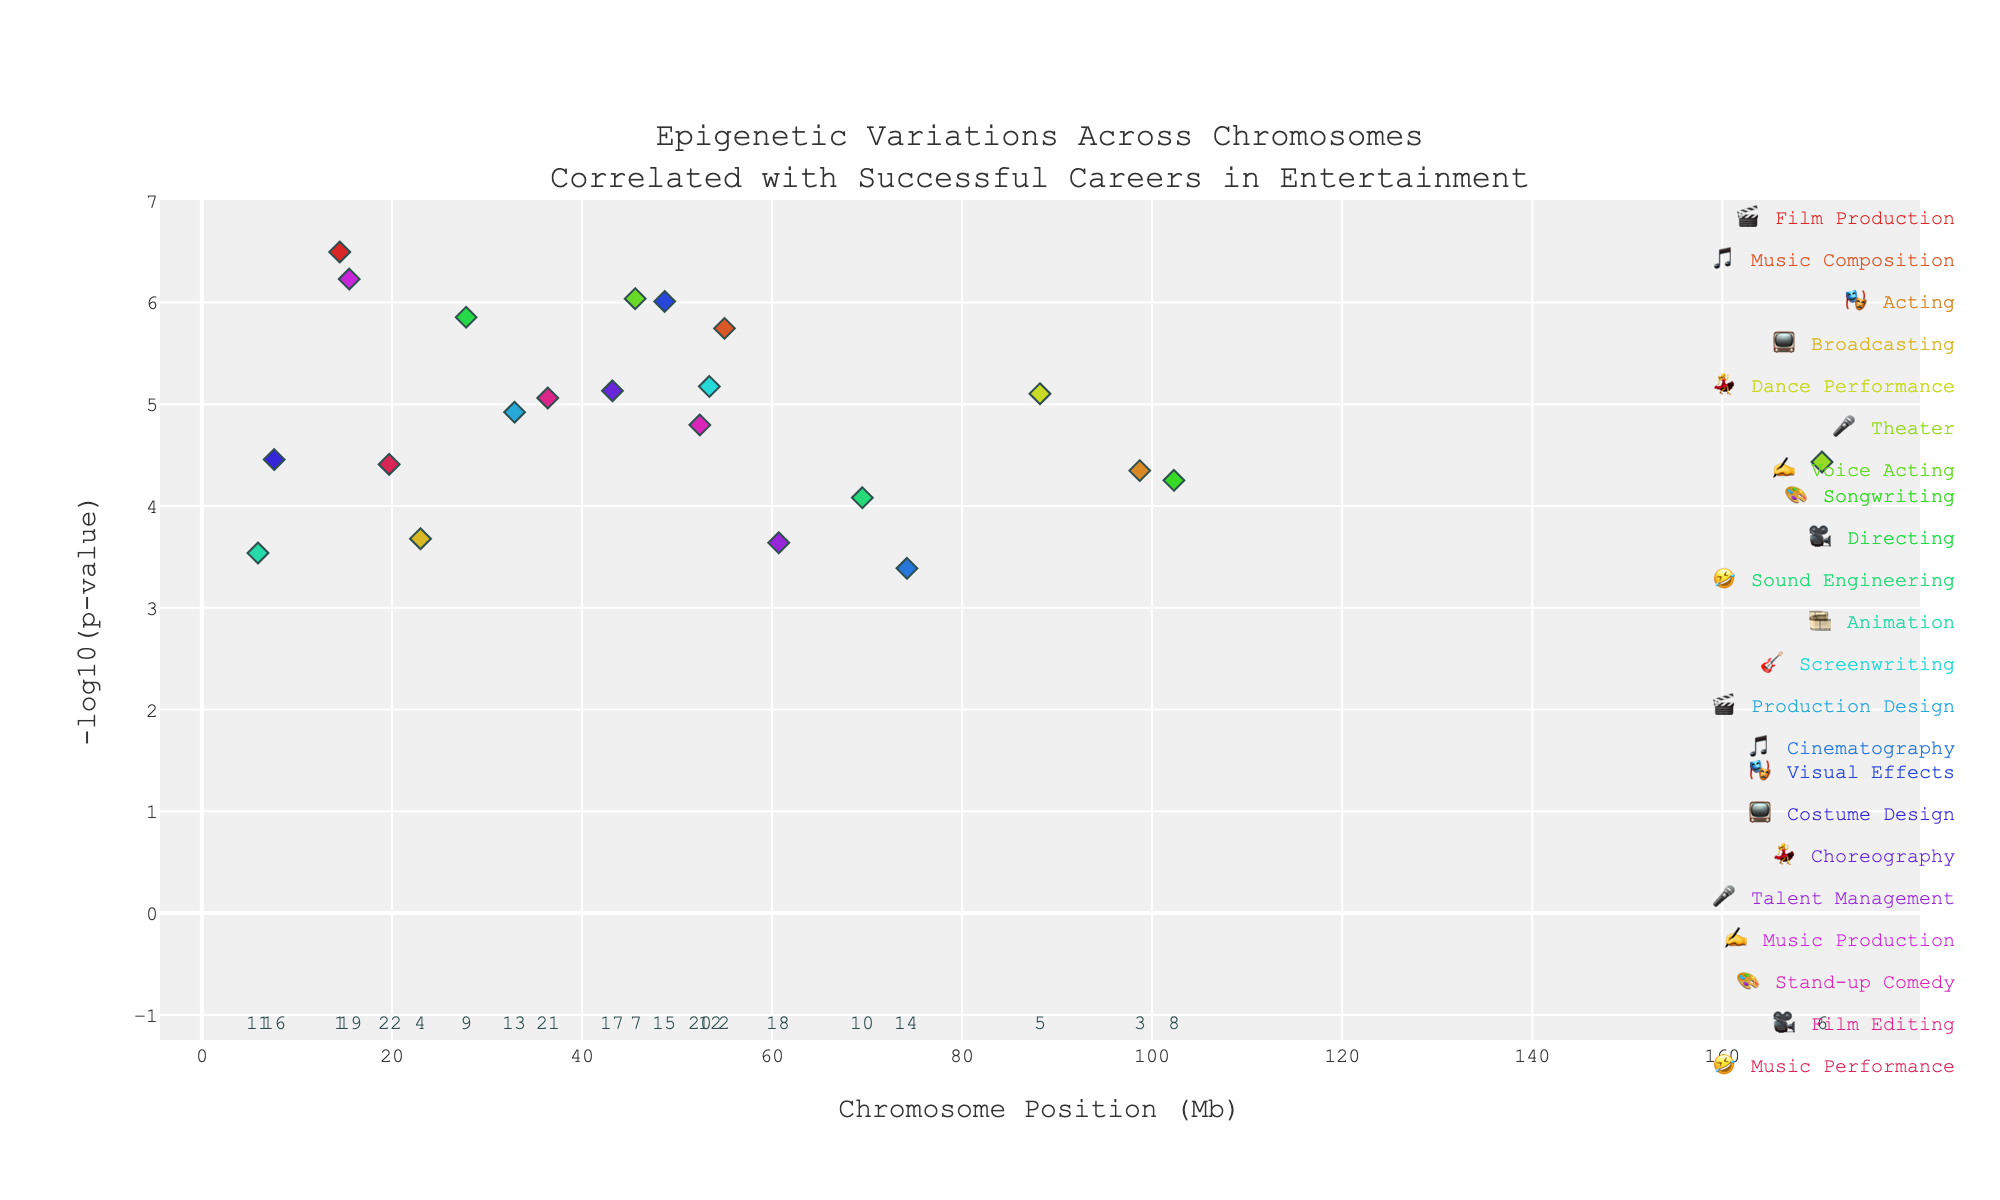What is the title of the plot? The title of the plot is usually located at the top center of the figure. It provides an overview of what the plot is about. In this case, it's about epigenetic variations across chromosomes correlated with successful careers in the entertainment industry.
Answer: Epigenetic Variations Across Chromosomes Correlated with Successful Careers in Entertainment How many data points are there for chromosome 7? To count the data points for chromosome 7, locate chromosome 7 on the x-axis and count the number of markers (points) shown. Each marker represents a data point.
Answer: 1 Which gene on chromosome 5 shows epigenetic variation, and what is its associated entertainment field? Identify chromosome 5 along the x-axis. The plot's hover text or legend might provide details on the associated gene and entertainment field.
Answer: MEF2C, Dance Performance What entertainment field is represented by the color at approximately the 50 Mb position on chromosome 2? Locate the position near 50 Mb on chromosome 2 on the x-axis and identify the marker. The color of the marker and the legend can help determine which entertainment field it represents.
Answer: Music Composition Which gene has the most significant p-value (smallest p-value) in the entire plot, and what chromosome is it on? The most significant p-value corresponds to the highest -log10(p-value). Identify the highest point in the plot and use the hover text or another figure annotation to find the gene and chromosome.
Answer: MTOR, Chromosome 1 What is the average position (in Mb) of the genes on chromosome 12? First, locate all data points corresponding to chromosome 12. Find their positions (in Mb), sum them up, and divide by the number of data points to get the average position. Chromosome 12 has only one gene at 53.4 Mb.
Answer: 53.4 Mb Between Film Production and Music Composition, which has a smaller p-value? Identify the points corresponding to Film Production and Music Composition using the hover text or the legend. Compare their p-values by looking at the height of their corresponding points in the plot (-log10(p-value)).
Answer: Film Production Which gene on chromosome 17 is involved in an entertainment field related to dance, and what is the -log10(p-value) for it? Locate chromosome 17 on the x-axis. Find the gene associated with dance (Choreography) using hover text or legend annotations and read its -log10(p-value) from the y-axis.
Answer: MAPT, 6.13 What are the entertainment fields associated with the genes on chromosome 4 and 5? Using the x-axis, locate chromosome 4 and 5. Identify the genes and their associated entertainment fields from the hover text or legend annotations.
Answer: Broadcasting (Chromosome 4), Dance Performance (Chromosome 5) Which chromosome has the most genes associated with successful careers in the entertainment industry? Count the number of data points (genes) for each chromosome and compare. The chromosome with the most vertical markers will have the most genes.
Answer: Chromosome 1 